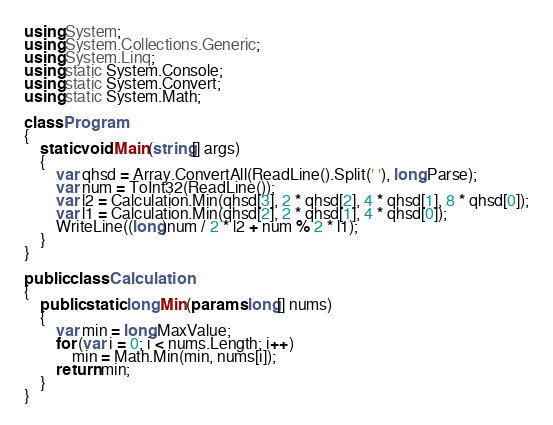Convert code to text. <code><loc_0><loc_0><loc_500><loc_500><_C#_>using System;
using System.Collections.Generic;
using System.Linq;
using static System.Console;
using static System.Convert;
using static System.Math;

class Program
{
    static void Main(string[] args)
    {
        var qhsd = Array.ConvertAll(ReadLine().Split(' '), long.Parse);
        var num = ToInt32(ReadLine());
        var l2 = Calculation.Min(qhsd[3], 2 * qhsd[2], 4 * qhsd[1], 8 * qhsd[0]);
        var l1 = Calculation.Min(qhsd[2], 2 * qhsd[1], 4 * qhsd[0]);
        WriteLine((long)num / 2 * l2 + num % 2 * l1);
    }
}

public class Calculation
{
    public static long Min(params long[] nums)
    {
        var min = long.MaxValue;
        for (var i = 0; i < nums.Length; i++)
            min = Math.Min(min, nums[i]);
        return min;
    }
}
</code> 